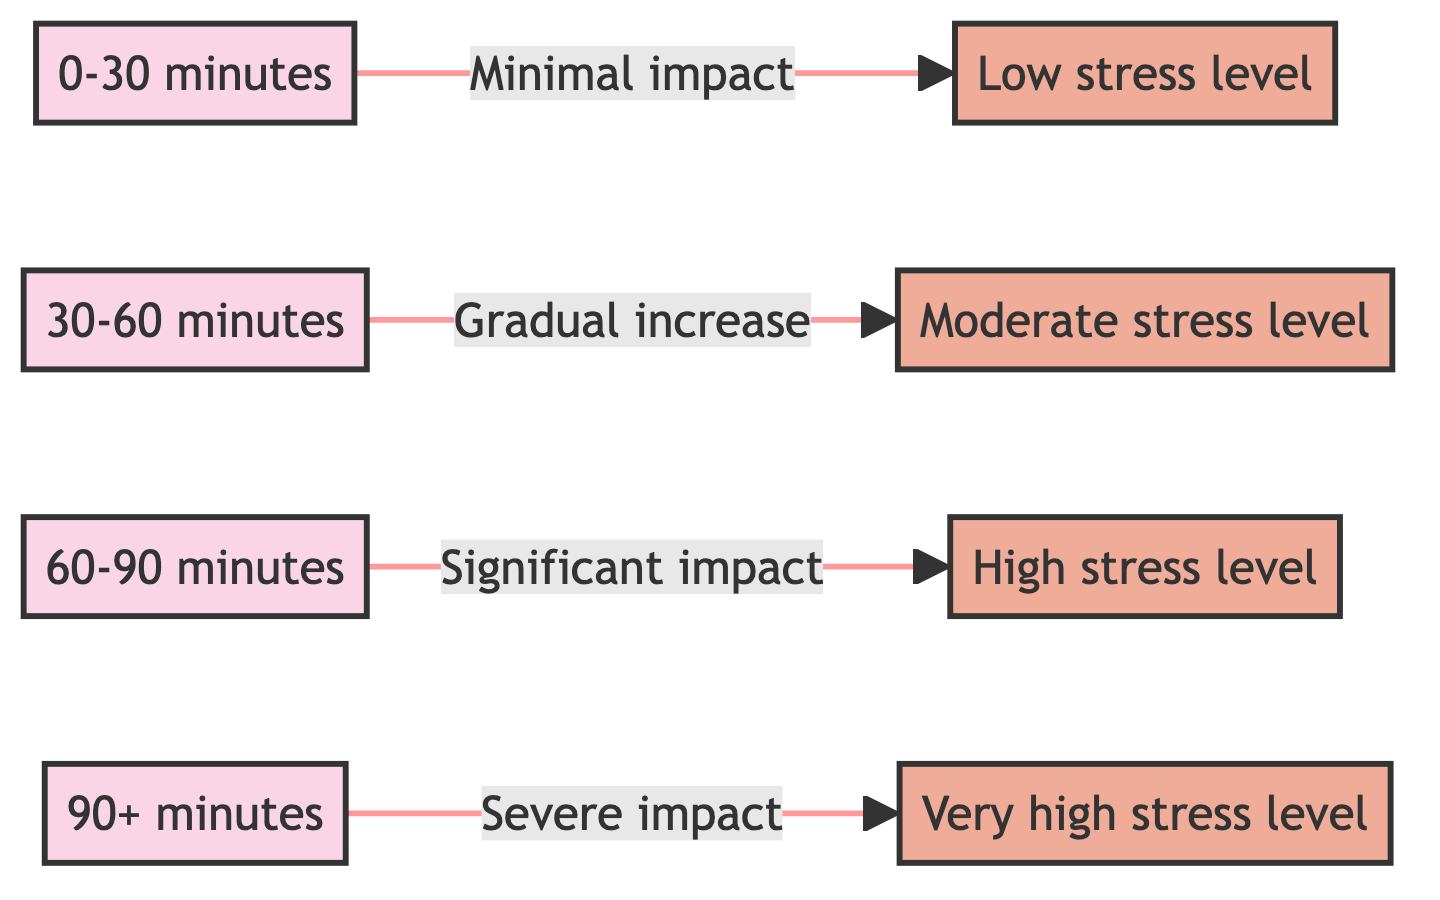What is the relationship between '30-60 minutes' and 'Moderate stress level'? The edge shows that '30-60 minutes' leads to 'Moderate stress level', indicating a gradual increase in stress with this commuting duration.
Answer: Gradual increase How many total nodes are in the diagram? By counting the distinct categories listed—commute durations and stress levels—there are 8 nodes in total.
Answer: 8 Which commuting duration has a 'Significant impact' on stress levels? The edge from '60-90 minutes' to 'High stress level' indicates that this duration represents a significant impact on stress levels.
Answer: 60-90 minutes Which stress level is associated with the '90+ minutes' commuting duration? The directed edge indicates that '90+ minutes' leads to 'Very high stress level', meaning this commuting duration is linked to an extreme level of stress.
Answer: Very high stress level What is the impact label associated with the '0-30 minutes' node? The edge leading from '0-30 minutes' to 'Low stress level' describes the impact as "Minimal impact," showing that this duration has little effect on stress.
Answer: Minimal impact How does the stress level change as commute duration increases from '30-60 minutes' to '60-90 minutes'? Moving from '30-60 minutes', which connects to 'Moderate stress level', to '60-90 minutes', which connects to 'High stress level', indicates a progression from moderate to significant impact on stress.
Answer: Increases What type of graph is represented in this diagram? The diagram is structured as a directed graph where nodes denote categories, and directed edges convey the relationship between commute duration and stress.
Answer: Directed graph What can be inferred about commuting durations longer than '90 minutes'? The diagram indicates that commuting durations longer than '90 minutes' lead to a 'Very high stress level', showing a considerable escalation in stress levels.
Answer: Severe impact 